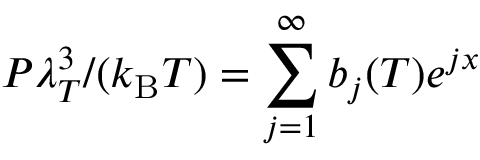<formula> <loc_0><loc_0><loc_500><loc_500>P \lambda _ { T } ^ { 3 } / ( k _ { B } T ) = \sum _ { j = 1 } ^ { \infty } b _ { j } ( T ) e ^ { j x }</formula> 